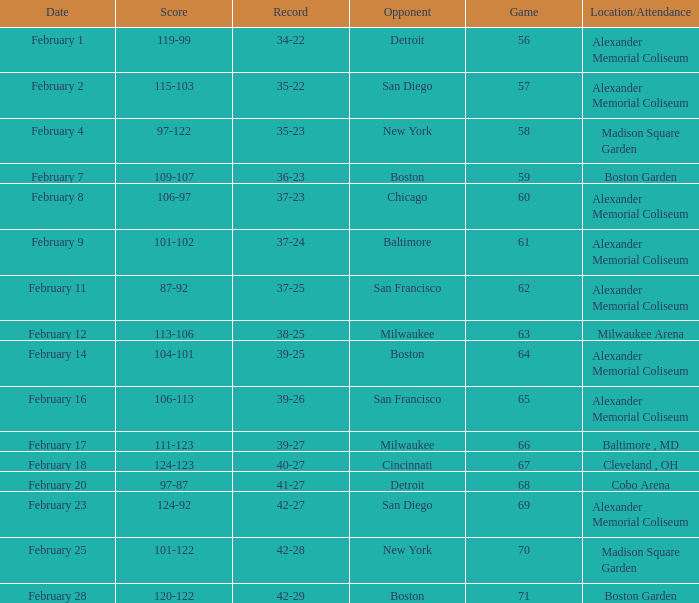What is the Game # that scored 87-92? 62.0. 